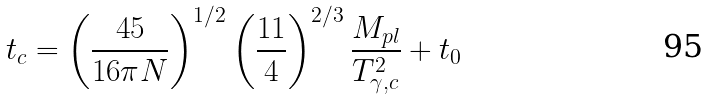Convert formula to latex. <formula><loc_0><loc_0><loc_500><loc_500>t _ { c } = \left ( \frac { 4 5 } { 1 6 \pi N } \right ) ^ { 1 / 2 } \left ( \frac { 1 1 } 4 \right ) ^ { 2 / 3 } \frac { M _ { p l } } { T _ { \gamma , c } ^ { 2 } } + t _ { 0 }</formula> 